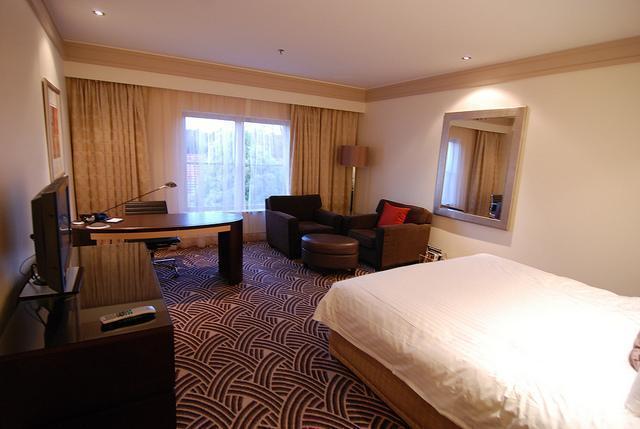The pillow on the couch is the same color as what?
Make your selection and explain in format: 'Answer: answer
Rationale: rationale.'
Options: Lemon, lime, tomato, orange. Answer: tomato.
Rationale: The pillow is red 